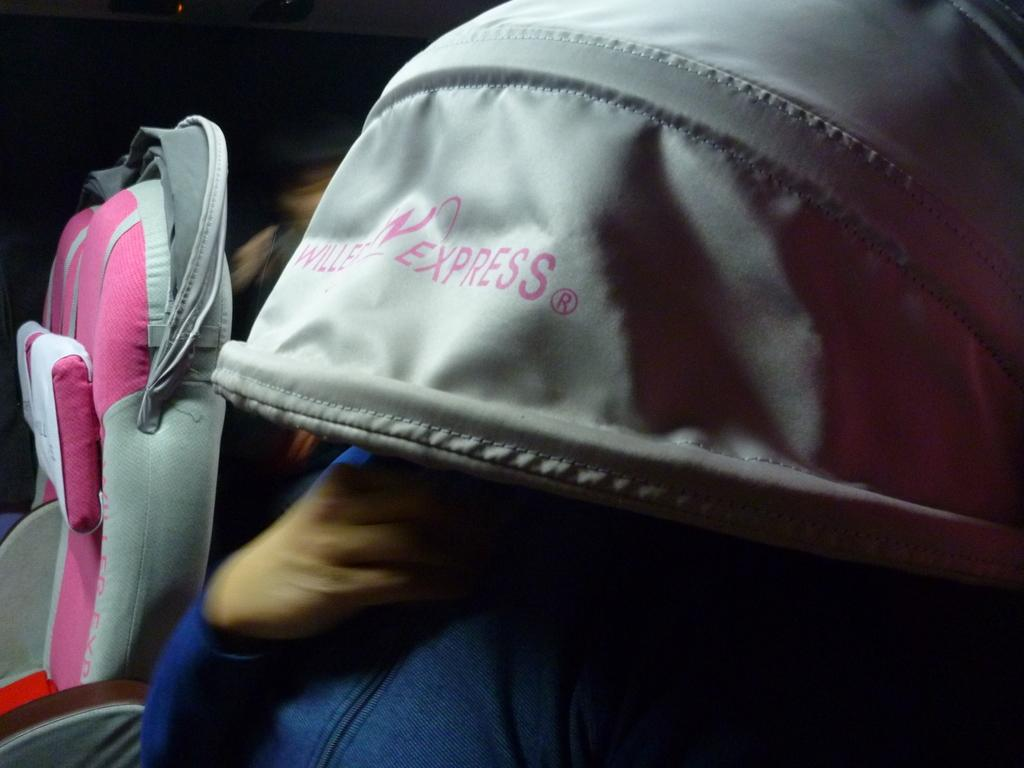What is the setting of the image? The image appears to be taken inside a vehicle. Can you describe the person in the image? There is a person sitting in the vehicle, and they have a cover over their face. What color is the seat on the left side of the vehicle? The seat on the left side of the vehicle is pink-colored. What type of knife can be seen in the image? There is no knife present in the image. Are there any bushes visible in the image? The image is taken inside a vehicle, so there are no bushes visible. 